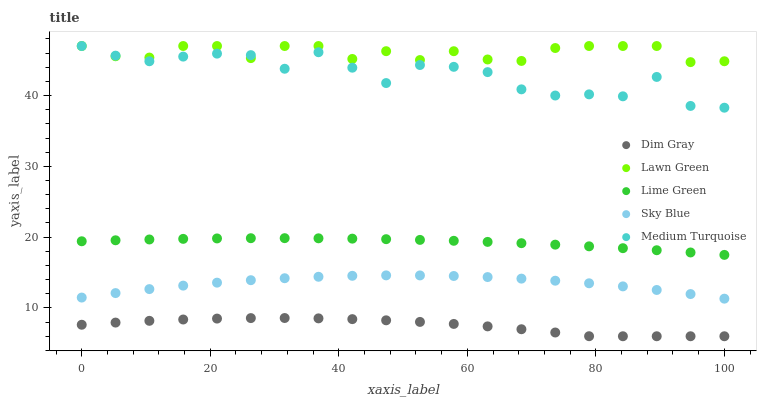Does Dim Gray have the minimum area under the curve?
Answer yes or no. Yes. Does Lawn Green have the maximum area under the curve?
Answer yes or no. Yes. Does Lime Green have the minimum area under the curve?
Answer yes or no. No. Does Lime Green have the maximum area under the curve?
Answer yes or no. No. Is Lime Green the smoothest?
Answer yes or no. Yes. Is Medium Turquoise the roughest?
Answer yes or no. Yes. Is Dim Gray the smoothest?
Answer yes or no. No. Is Dim Gray the roughest?
Answer yes or no. No. Does Dim Gray have the lowest value?
Answer yes or no. Yes. Does Lime Green have the lowest value?
Answer yes or no. No. Does Medium Turquoise have the highest value?
Answer yes or no. Yes. Does Lime Green have the highest value?
Answer yes or no. No. Is Dim Gray less than Medium Turquoise?
Answer yes or no. Yes. Is Medium Turquoise greater than Dim Gray?
Answer yes or no. Yes. Does Lawn Green intersect Medium Turquoise?
Answer yes or no. Yes. Is Lawn Green less than Medium Turquoise?
Answer yes or no. No. Is Lawn Green greater than Medium Turquoise?
Answer yes or no. No. Does Dim Gray intersect Medium Turquoise?
Answer yes or no. No. 